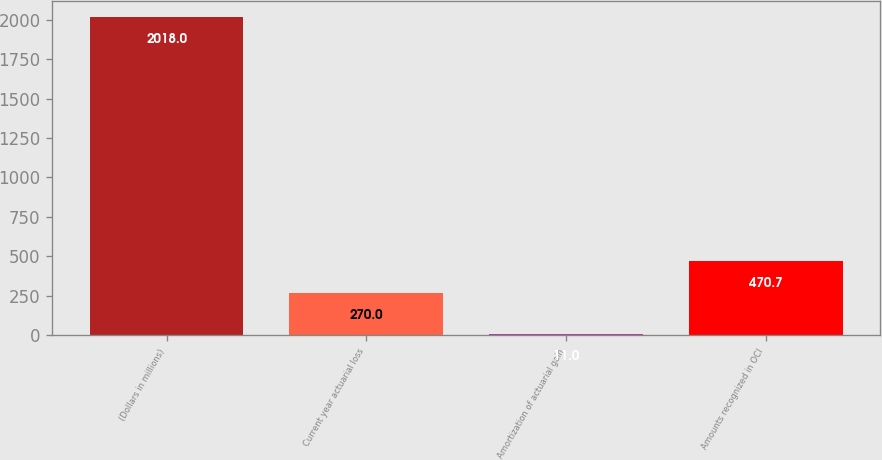Convert chart. <chart><loc_0><loc_0><loc_500><loc_500><bar_chart><fcel>(Dollars in millions)<fcel>Current year actuarial loss<fcel>Amortization of actuarial gain<fcel>Amounts recognized in OCI<nl><fcel>2018<fcel>270<fcel>11<fcel>470.7<nl></chart> 